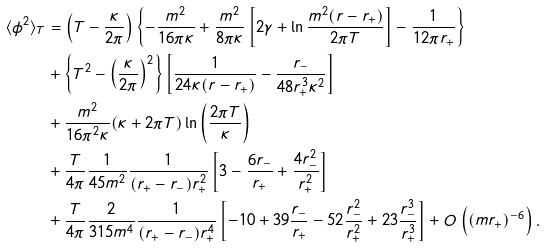Convert formula to latex. <formula><loc_0><loc_0><loc_500><loc_500>\langle \phi ^ { 2 } \rangle _ { T } & = \left ( T - \frac { \kappa } { 2 \pi } \right ) \left \{ - \frac { m ^ { 2 } } { 1 6 \pi \kappa } + \frac { m ^ { 2 } } { 8 \pi \kappa } \left [ 2 \gamma + \ln \frac { m ^ { 2 } ( r - r _ { + } ) } { 2 \pi T } \right ] - \frac { 1 } { 1 2 \pi r _ { + } } \right \} \\ & + \left \{ T ^ { 2 } - \left ( \frac { \kappa } { 2 \pi } \right ) ^ { 2 } \right \} \left [ \frac { 1 } { 2 4 \kappa ( r - r _ { + } ) } - \frac { r _ { - } } { 4 8 r _ { + } ^ { 3 } \kappa ^ { 2 } } \right ] \\ & + \frac { m ^ { 2 } } { 1 6 \pi ^ { 2 } \kappa } ( \kappa + 2 \pi T ) \ln \left ( \frac { 2 \pi T } { \kappa } \right ) \\ & + \frac { T } { 4 \pi } \frac { 1 } { 4 5 m ^ { 2 } } \frac { 1 } { ( r _ { + } - r _ { - } ) r _ { + } ^ { 2 } } \left [ 3 - \frac { 6 r _ { - } } { r _ { + } } + \frac { 4 r _ { - } ^ { 2 } } { r _ { + } ^ { 2 } } \right ] \\ & + \frac { T } { 4 \pi } \frac { 2 } { 3 1 5 m ^ { 4 } } \frac { 1 } { ( r _ { + } - r _ { - } ) r _ { + } ^ { 4 } } \left [ - 1 0 + 3 9 \frac { r _ { - } } { r _ { + } } - 5 2 \frac { r _ { - } ^ { 2 } } { r _ { + } ^ { 2 } } + 2 3 \frac { r _ { - } ^ { 3 } } { r _ { + } ^ { 3 } } \right ] + O \left ( ( m r _ { + } ) ^ { - 6 } \right ) .</formula> 